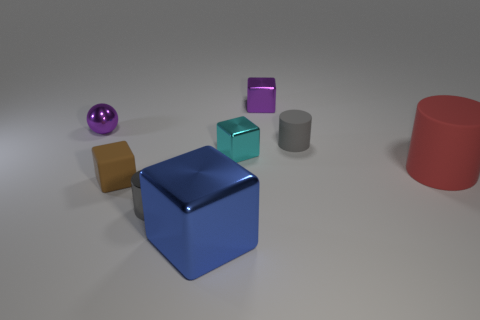There is a small gray thing left of the cyan metallic block; what number of gray rubber cylinders are behind it?
Ensure brevity in your answer.  1. What number of other things are there of the same size as the cyan metal object?
Ensure brevity in your answer.  5. There is a tiny purple object that is to the left of the large metallic thing; is its shape the same as the tiny gray metal thing?
Offer a terse response. No. There is a gray thing that is behind the large matte object; what is it made of?
Provide a succinct answer. Rubber. What shape is the tiny shiny thing that is the same color as the metal sphere?
Keep it short and to the point. Cube. Is there a small gray cylinder that has the same material as the tiny cyan thing?
Your response must be concise. Yes. What size is the brown rubber object?
Your answer should be compact. Small. How many gray objects are either tiny cylinders or tiny metal spheres?
Provide a short and direct response. 2. What number of other brown matte things are the same shape as the brown matte object?
Ensure brevity in your answer.  0. What number of brown metallic things have the same size as the cyan metal object?
Provide a succinct answer. 0. 